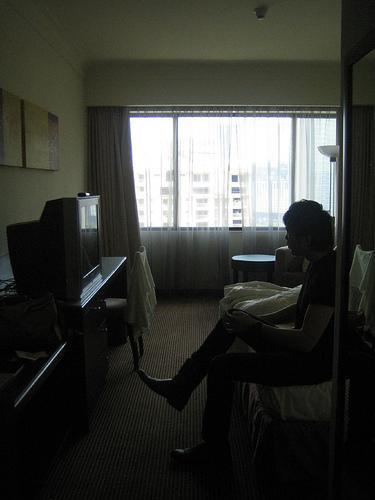Where is the woman sitting in?
Answer the question by selecting the correct answer among the 4 following choices.
Options: Bedroom, office, hotel room, library. Hotel room. 